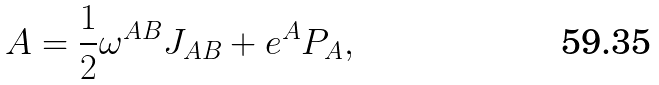<formula> <loc_0><loc_0><loc_500><loc_500>A = \frac { 1 } { 2 } \omega ^ { A B } J _ { A B } + e ^ { A } P _ { A } ,</formula> 